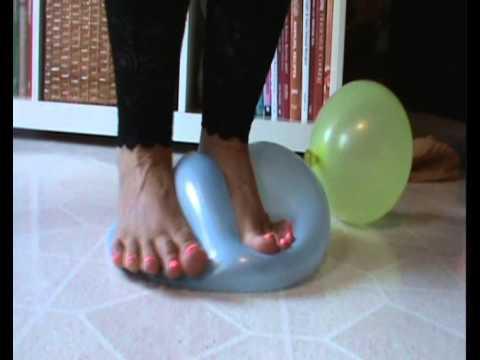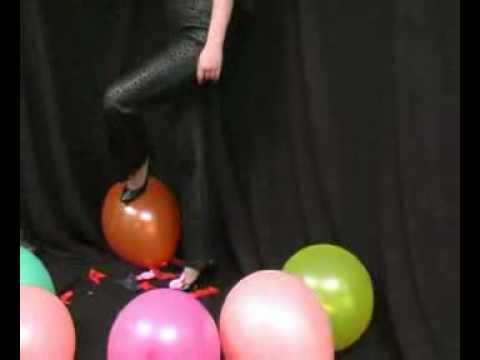The first image is the image on the left, the second image is the image on the right. Examine the images to the left and right. Is the description "There are two women stepping on balloons." accurate? Answer yes or no. Yes. The first image is the image on the left, the second image is the image on the right. Evaluate the accuracy of this statement regarding the images: "Someone is stepping on a blue balloon.". Is it true? Answer yes or no. Yes. 